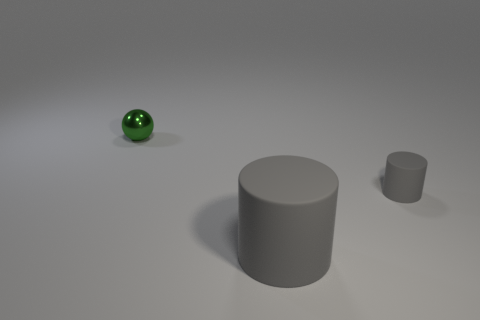Add 3 yellow metal cylinders. How many objects exist? 6 Subtract all balls. How many objects are left? 2 Subtract all small metal balls. Subtract all small gray cylinders. How many objects are left? 1 Add 2 tiny gray matte objects. How many tiny gray matte objects are left? 3 Add 2 large red shiny things. How many large red shiny things exist? 2 Subtract 0 cyan blocks. How many objects are left? 3 